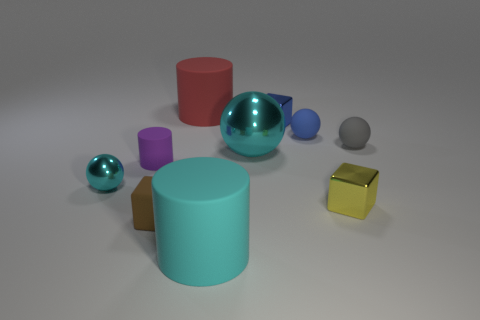Subtract 1 balls. How many balls are left? 3 Subtract all cubes. How many objects are left? 7 Add 9 big cyan rubber cylinders. How many big cyan rubber cylinders exist? 10 Subtract 0 green blocks. How many objects are left? 10 Subtract all large blue metallic things. Subtract all cyan metal balls. How many objects are left? 8 Add 1 large metal things. How many large metal things are left? 2 